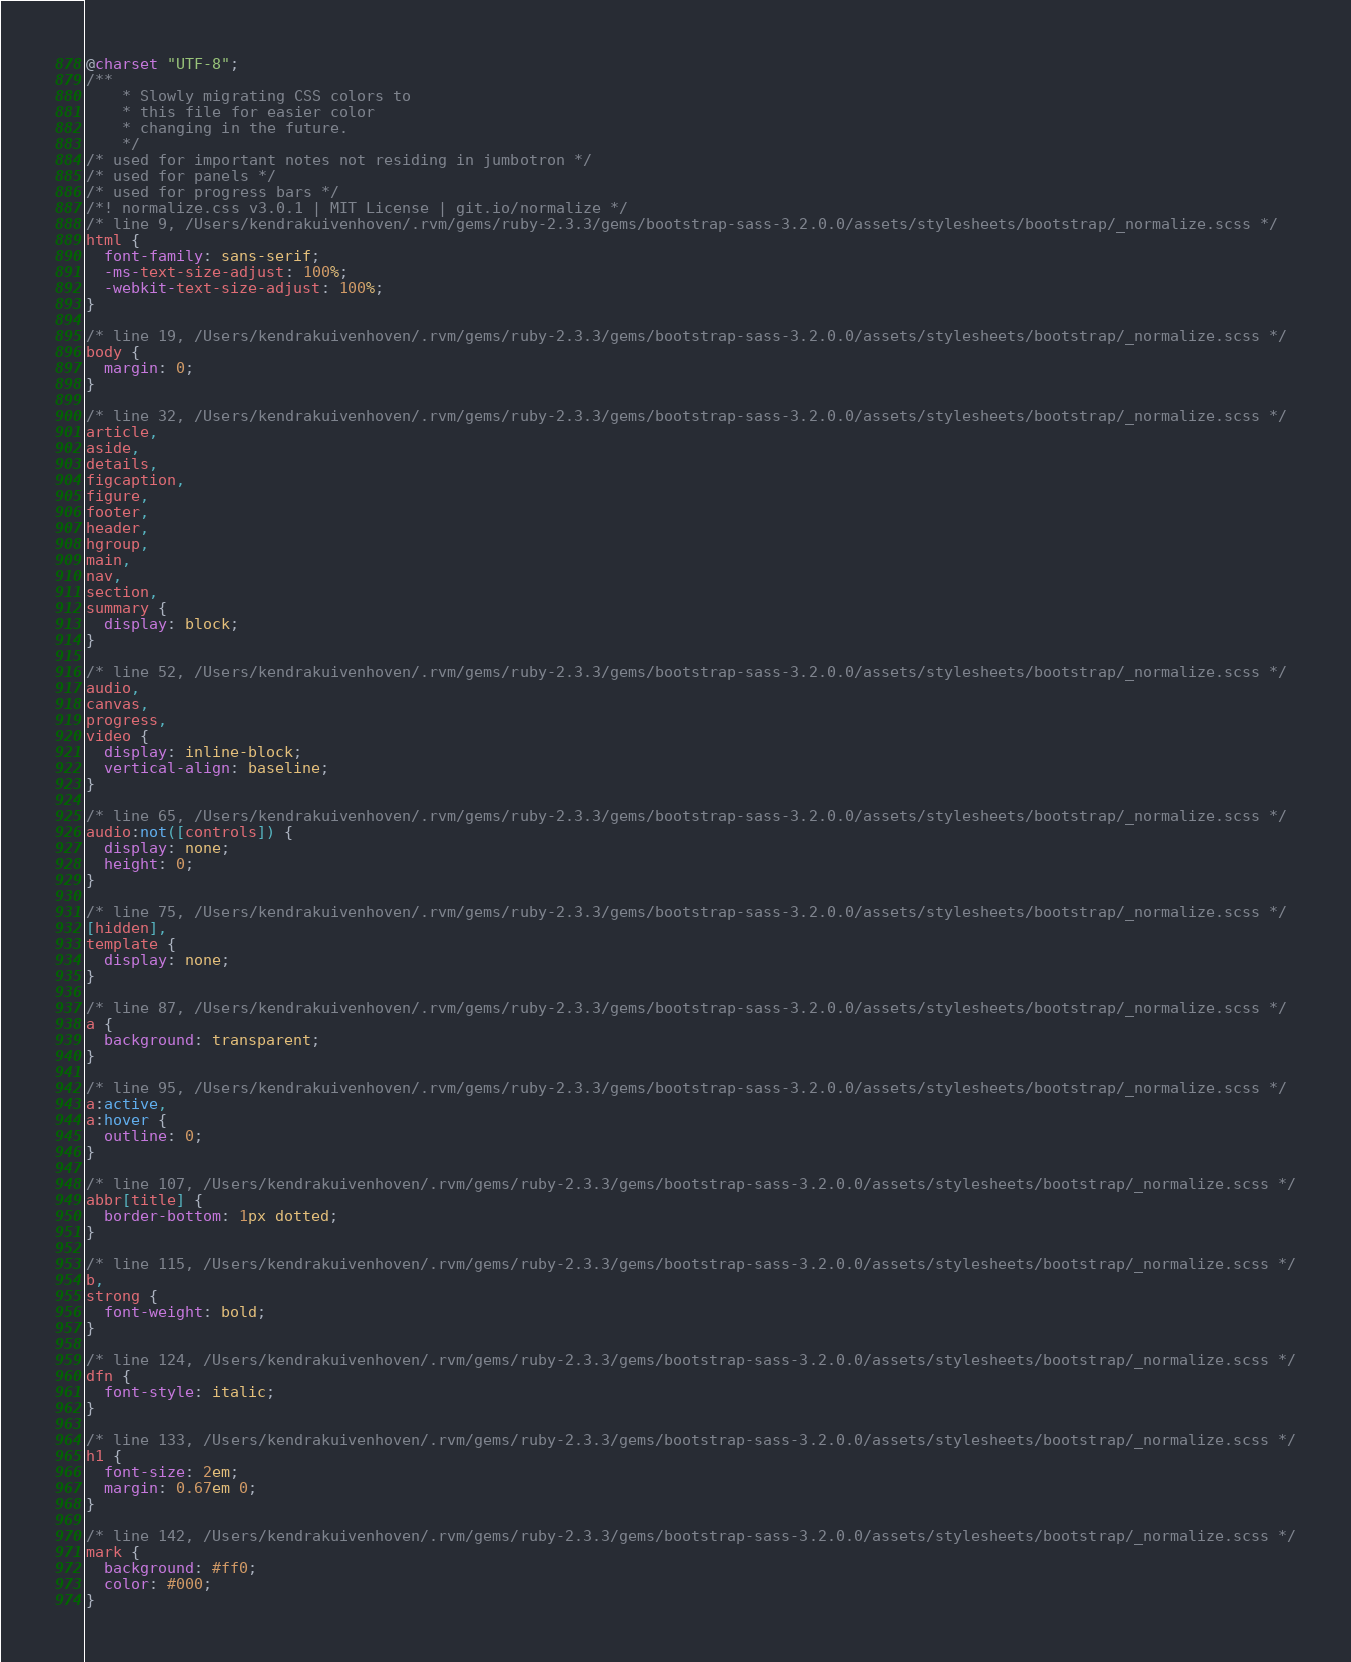<code> <loc_0><loc_0><loc_500><loc_500><_CSS_>@charset "UTF-8";
/**
	* Slowly migrating CSS colors to 
	* this file for easier color 
	* changing in the future.
	*/
/* used for important notes not residing in jumbotron */
/* used for panels */
/* used for progress bars */
/*! normalize.css v3.0.1 | MIT License | git.io/normalize */
/* line 9, /Users/kendrakuivenhoven/.rvm/gems/ruby-2.3.3/gems/bootstrap-sass-3.2.0.0/assets/stylesheets/bootstrap/_normalize.scss */
html {
  font-family: sans-serif;
  -ms-text-size-adjust: 100%;
  -webkit-text-size-adjust: 100%;
}

/* line 19, /Users/kendrakuivenhoven/.rvm/gems/ruby-2.3.3/gems/bootstrap-sass-3.2.0.0/assets/stylesheets/bootstrap/_normalize.scss */
body {
  margin: 0;
}

/* line 32, /Users/kendrakuivenhoven/.rvm/gems/ruby-2.3.3/gems/bootstrap-sass-3.2.0.0/assets/stylesheets/bootstrap/_normalize.scss */
article,
aside,
details,
figcaption,
figure,
footer,
header,
hgroup,
main,
nav,
section,
summary {
  display: block;
}

/* line 52, /Users/kendrakuivenhoven/.rvm/gems/ruby-2.3.3/gems/bootstrap-sass-3.2.0.0/assets/stylesheets/bootstrap/_normalize.scss */
audio,
canvas,
progress,
video {
  display: inline-block;
  vertical-align: baseline;
}

/* line 65, /Users/kendrakuivenhoven/.rvm/gems/ruby-2.3.3/gems/bootstrap-sass-3.2.0.0/assets/stylesheets/bootstrap/_normalize.scss */
audio:not([controls]) {
  display: none;
  height: 0;
}

/* line 75, /Users/kendrakuivenhoven/.rvm/gems/ruby-2.3.3/gems/bootstrap-sass-3.2.0.0/assets/stylesheets/bootstrap/_normalize.scss */
[hidden],
template {
  display: none;
}

/* line 87, /Users/kendrakuivenhoven/.rvm/gems/ruby-2.3.3/gems/bootstrap-sass-3.2.0.0/assets/stylesheets/bootstrap/_normalize.scss */
a {
  background: transparent;
}

/* line 95, /Users/kendrakuivenhoven/.rvm/gems/ruby-2.3.3/gems/bootstrap-sass-3.2.0.0/assets/stylesheets/bootstrap/_normalize.scss */
a:active,
a:hover {
  outline: 0;
}

/* line 107, /Users/kendrakuivenhoven/.rvm/gems/ruby-2.3.3/gems/bootstrap-sass-3.2.0.0/assets/stylesheets/bootstrap/_normalize.scss */
abbr[title] {
  border-bottom: 1px dotted;
}

/* line 115, /Users/kendrakuivenhoven/.rvm/gems/ruby-2.3.3/gems/bootstrap-sass-3.2.0.0/assets/stylesheets/bootstrap/_normalize.scss */
b,
strong {
  font-weight: bold;
}

/* line 124, /Users/kendrakuivenhoven/.rvm/gems/ruby-2.3.3/gems/bootstrap-sass-3.2.0.0/assets/stylesheets/bootstrap/_normalize.scss */
dfn {
  font-style: italic;
}

/* line 133, /Users/kendrakuivenhoven/.rvm/gems/ruby-2.3.3/gems/bootstrap-sass-3.2.0.0/assets/stylesheets/bootstrap/_normalize.scss */
h1 {
  font-size: 2em;
  margin: 0.67em 0;
}

/* line 142, /Users/kendrakuivenhoven/.rvm/gems/ruby-2.3.3/gems/bootstrap-sass-3.2.0.0/assets/stylesheets/bootstrap/_normalize.scss */
mark {
  background: #ff0;
  color: #000;
}
</code> 